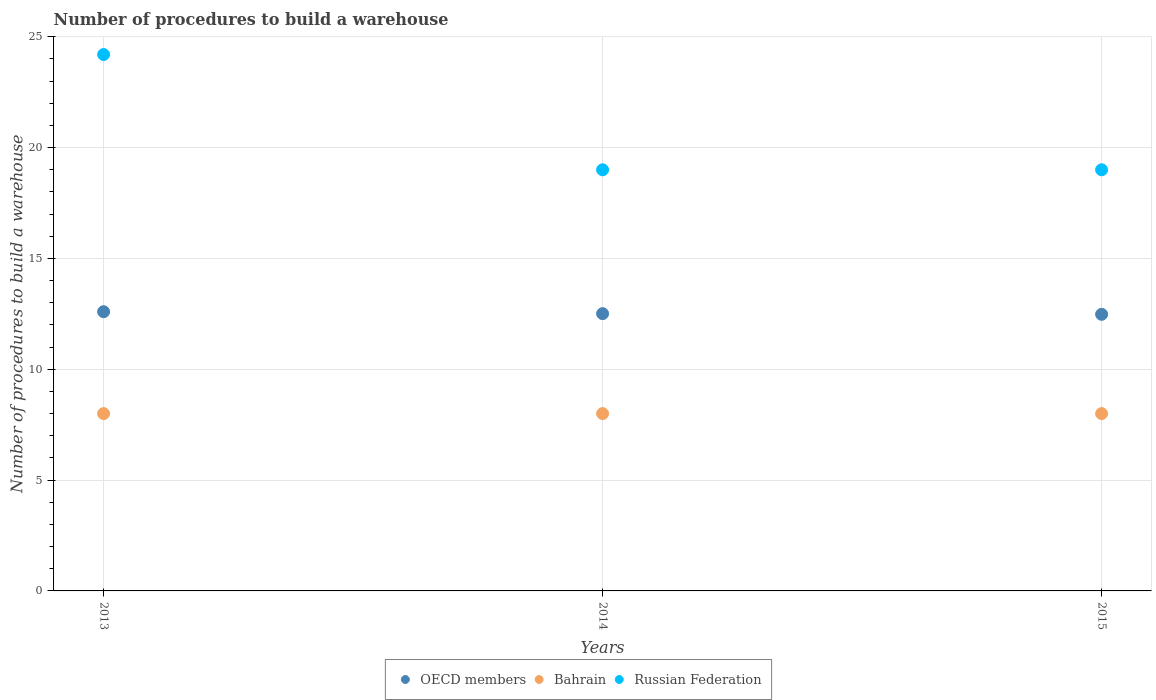What is the number of procedures to build a warehouse in in Bahrain in 2015?
Offer a very short reply. 8. Across all years, what is the maximum number of procedures to build a warehouse in in OECD members?
Your answer should be compact. 12.6. Across all years, what is the minimum number of procedures to build a warehouse in in Russian Federation?
Provide a succinct answer. 19. In which year was the number of procedures to build a warehouse in in Bahrain minimum?
Ensure brevity in your answer.  2013. What is the total number of procedures to build a warehouse in in OECD members in the graph?
Provide a short and direct response. 37.59. What is the difference between the number of procedures to build a warehouse in in OECD members in 2014 and that in 2015?
Make the answer very short. 0.03. What is the difference between the number of procedures to build a warehouse in in OECD members in 2015 and the number of procedures to build a warehouse in in Bahrain in 2014?
Your answer should be compact. 4.48. What is the average number of procedures to build a warehouse in in Bahrain per year?
Make the answer very short. 8. In the year 2013, what is the difference between the number of procedures to build a warehouse in in Russian Federation and number of procedures to build a warehouse in in Bahrain?
Your response must be concise. 16.2. In how many years, is the number of procedures to build a warehouse in in Bahrain greater than 23?
Offer a very short reply. 0. What is the ratio of the number of procedures to build a warehouse in in Russian Federation in 2013 to that in 2015?
Ensure brevity in your answer.  1.27. What is the difference between the highest and the second highest number of procedures to build a warehouse in in Russian Federation?
Your response must be concise. 5.2. In how many years, is the number of procedures to build a warehouse in in Russian Federation greater than the average number of procedures to build a warehouse in in Russian Federation taken over all years?
Provide a succinct answer. 1. Is the sum of the number of procedures to build a warehouse in in Bahrain in 2014 and 2015 greater than the maximum number of procedures to build a warehouse in in OECD members across all years?
Give a very brief answer. Yes. Is the number of procedures to build a warehouse in in Russian Federation strictly greater than the number of procedures to build a warehouse in in Bahrain over the years?
Your answer should be compact. Yes. How many dotlines are there?
Provide a short and direct response. 3. What is the difference between two consecutive major ticks on the Y-axis?
Your answer should be very brief. 5. Does the graph contain any zero values?
Offer a terse response. No. What is the title of the graph?
Keep it short and to the point. Number of procedures to build a warehouse. Does "Panama" appear as one of the legend labels in the graph?
Your answer should be compact. No. What is the label or title of the X-axis?
Your answer should be compact. Years. What is the label or title of the Y-axis?
Provide a short and direct response. Number of procedures to build a warehouse. What is the Number of procedures to build a warehouse in OECD members in 2013?
Offer a very short reply. 12.6. What is the Number of procedures to build a warehouse in Russian Federation in 2013?
Give a very brief answer. 24.2. What is the Number of procedures to build a warehouse in OECD members in 2014?
Keep it short and to the point. 12.51. What is the Number of procedures to build a warehouse in Bahrain in 2014?
Make the answer very short. 8. What is the Number of procedures to build a warehouse of OECD members in 2015?
Ensure brevity in your answer.  12.48. Across all years, what is the maximum Number of procedures to build a warehouse in OECD members?
Offer a very short reply. 12.6. Across all years, what is the maximum Number of procedures to build a warehouse of Russian Federation?
Keep it short and to the point. 24.2. Across all years, what is the minimum Number of procedures to build a warehouse in OECD members?
Give a very brief answer. 12.48. Across all years, what is the minimum Number of procedures to build a warehouse of Bahrain?
Your answer should be very brief. 8. What is the total Number of procedures to build a warehouse of OECD members in the graph?
Your answer should be compact. 37.59. What is the total Number of procedures to build a warehouse of Russian Federation in the graph?
Your answer should be very brief. 62.2. What is the difference between the Number of procedures to build a warehouse in OECD members in 2013 and that in 2014?
Your answer should be compact. 0.09. What is the difference between the Number of procedures to build a warehouse in Russian Federation in 2013 and that in 2014?
Your answer should be very brief. 5.2. What is the difference between the Number of procedures to build a warehouse in OECD members in 2013 and that in 2015?
Make the answer very short. 0.12. What is the difference between the Number of procedures to build a warehouse of Bahrain in 2013 and that in 2015?
Offer a very short reply. 0. What is the difference between the Number of procedures to build a warehouse in Russian Federation in 2013 and that in 2015?
Offer a terse response. 5.2. What is the difference between the Number of procedures to build a warehouse of OECD members in 2014 and that in 2015?
Your answer should be very brief. 0.03. What is the difference between the Number of procedures to build a warehouse in Russian Federation in 2014 and that in 2015?
Make the answer very short. 0. What is the difference between the Number of procedures to build a warehouse in OECD members in 2013 and the Number of procedures to build a warehouse in Bahrain in 2014?
Keep it short and to the point. 4.6. What is the difference between the Number of procedures to build a warehouse of OECD members in 2013 and the Number of procedures to build a warehouse of Russian Federation in 2014?
Provide a short and direct response. -6.4. What is the difference between the Number of procedures to build a warehouse of Bahrain in 2013 and the Number of procedures to build a warehouse of Russian Federation in 2014?
Ensure brevity in your answer.  -11. What is the difference between the Number of procedures to build a warehouse in OECD members in 2013 and the Number of procedures to build a warehouse in Bahrain in 2015?
Give a very brief answer. 4.6. What is the difference between the Number of procedures to build a warehouse in OECD members in 2013 and the Number of procedures to build a warehouse in Russian Federation in 2015?
Your answer should be compact. -6.4. What is the difference between the Number of procedures to build a warehouse in Bahrain in 2013 and the Number of procedures to build a warehouse in Russian Federation in 2015?
Make the answer very short. -11. What is the difference between the Number of procedures to build a warehouse of OECD members in 2014 and the Number of procedures to build a warehouse of Bahrain in 2015?
Provide a succinct answer. 4.51. What is the difference between the Number of procedures to build a warehouse in OECD members in 2014 and the Number of procedures to build a warehouse in Russian Federation in 2015?
Provide a succinct answer. -6.49. What is the average Number of procedures to build a warehouse of OECD members per year?
Provide a succinct answer. 12.53. What is the average Number of procedures to build a warehouse in Russian Federation per year?
Give a very brief answer. 20.73. In the year 2013, what is the difference between the Number of procedures to build a warehouse of OECD members and Number of procedures to build a warehouse of Bahrain?
Offer a very short reply. 4.6. In the year 2013, what is the difference between the Number of procedures to build a warehouse in OECD members and Number of procedures to build a warehouse in Russian Federation?
Provide a succinct answer. -11.6. In the year 2013, what is the difference between the Number of procedures to build a warehouse in Bahrain and Number of procedures to build a warehouse in Russian Federation?
Your answer should be compact. -16.2. In the year 2014, what is the difference between the Number of procedures to build a warehouse of OECD members and Number of procedures to build a warehouse of Bahrain?
Offer a terse response. 4.51. In the year 2014, what is the difference between the Number of procedures to build a warehouse in OECD members and Number of procedures to build a warehouse in Russian Federation?
Offer a very short reply. -6.49. In the year 2014, what is the difference between the Number of procedures to build a warehouse of Bahrain and Number of procedures to build a warehouse of Russian Federation?
Your response must be concise. -11. In the year 2015, what is the difference between the Number of procedures to build a warehouse in OECD members and Number of procedures to build a warehouse in Bahrain?
Make the answer very short. 4.48. In the year 2015, what is the difference between the Number of procedures to build a warehouse of OECD members and Number of procedures to build a warehouse of Russian Federation?
Your answer should be very brief. -6.52. In the year 2015, what is the difference between the Number of procedures to build a warehouse of Bahrain and Number of procedures to build a warehouse of Russian Federation?
Make the answer very short. -11. What is the ratio of the Number of procedures to build a warehouse in OECD members in 2013 to that in 2014?
Make the answer very short. 1.01. What is the ratio of the Number of procedures to build a warehouse in Russian Federation in 2013 to that in 2014?
Give a very brief answer. 1.27. What is the ratio of the Number of procedures to build a warehouse in OECD members in 2013 to that in 2015?
Provide a succinct answer. 1.01. What is the ratio of the Number of procedures to build a warehouse of Russian Federation in 2013 to that in 2015?
Make the answer very short. 1.27. What is the difference between the highest and the second highest Number of procedures to build a warehouse in OECD members?
Offer a terse response. 0.09. What is the difference between the highest and the second highest Number of procedures to build a warehouse in Russian Federation?
Give a very brief answer. 5.2. What is the difference between the highest and the lowest Number of procedures to build a warehouse of OECD members?
Your answer should be compact. 0.12. What is the difference between the highest and the lowest Number of procedures to build a warehouse in Russian Federation?
Your response must be concise. 5.2. 